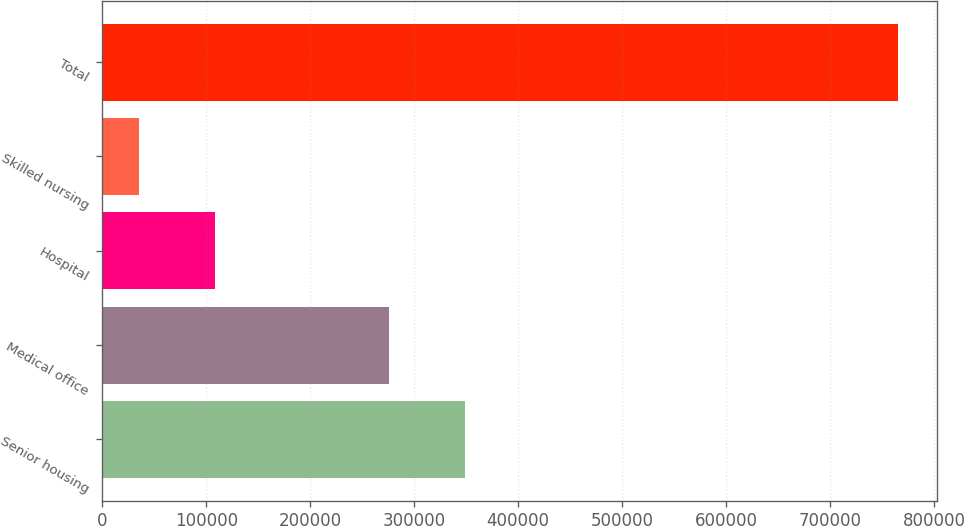<chart> <loc_0><loc_0><loc_500><loc_500><bar_chart><fcel>Senior housing<fcel>Medical office<fcel>Hospital<fcel>Skilled nursing<fcel>Total<nl><fcel>348941<fcel>275951<fcel>108162<fcel>35172<fcel>765074<nl></chart> 